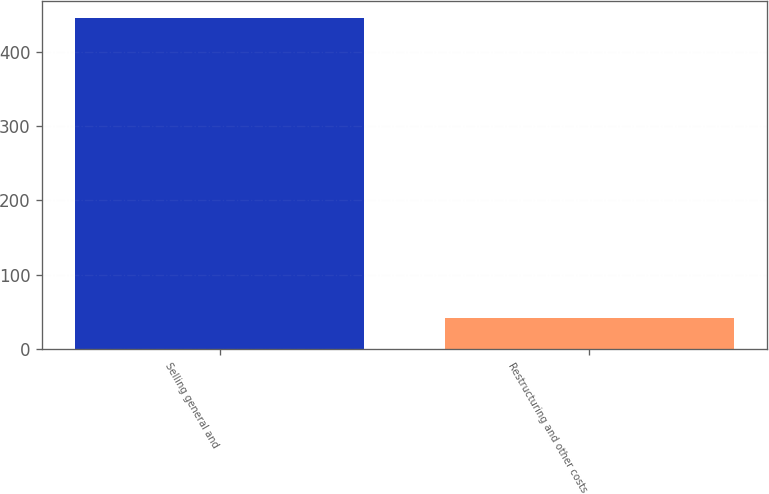Convert chart to OTSL. <chart><loc_0><loc_0><loc_500><loc_500><bar_chart><fcel>Selling general and<fcel>Restructuring and other costs<nl><fcel>445.7<fcel>41.5<nl></chart> 